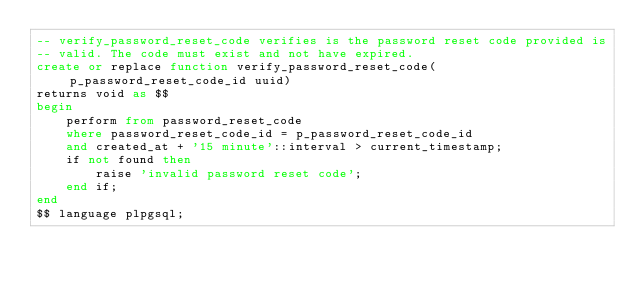<code> <loc_0><loc_0><loc_500><loc_500><_SQL_>-- verify_password_reset_code verifies is the password reset code provided is
-- valid. The code must exist and not have expired.
create or replace function verify_password_reset_code(p_password_reset_code_id uuid)
returns void as $$
begin
    perform from password_reset_code
    where password_reset_code_id = p_password_reset_code_id
    and created_at + '15 minute'::interval > current_timestamp;
    if not found then
        raise 'invalid password reset code';
    end if;
end
$$ language plpgsql;
</code> 